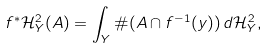Convert formula to latex. <formula><loc_0><loc_0><loc_500><loc_500>f ^ { * } \mathcal { H } ^ { 2 } _ { Y } ( A ) = \int _ { Y } \# ( A \cap f ^ { - 1 } ( y ) ) \, d \mathcal { H } ^ { 2 } _ { Y } ,</formula> 